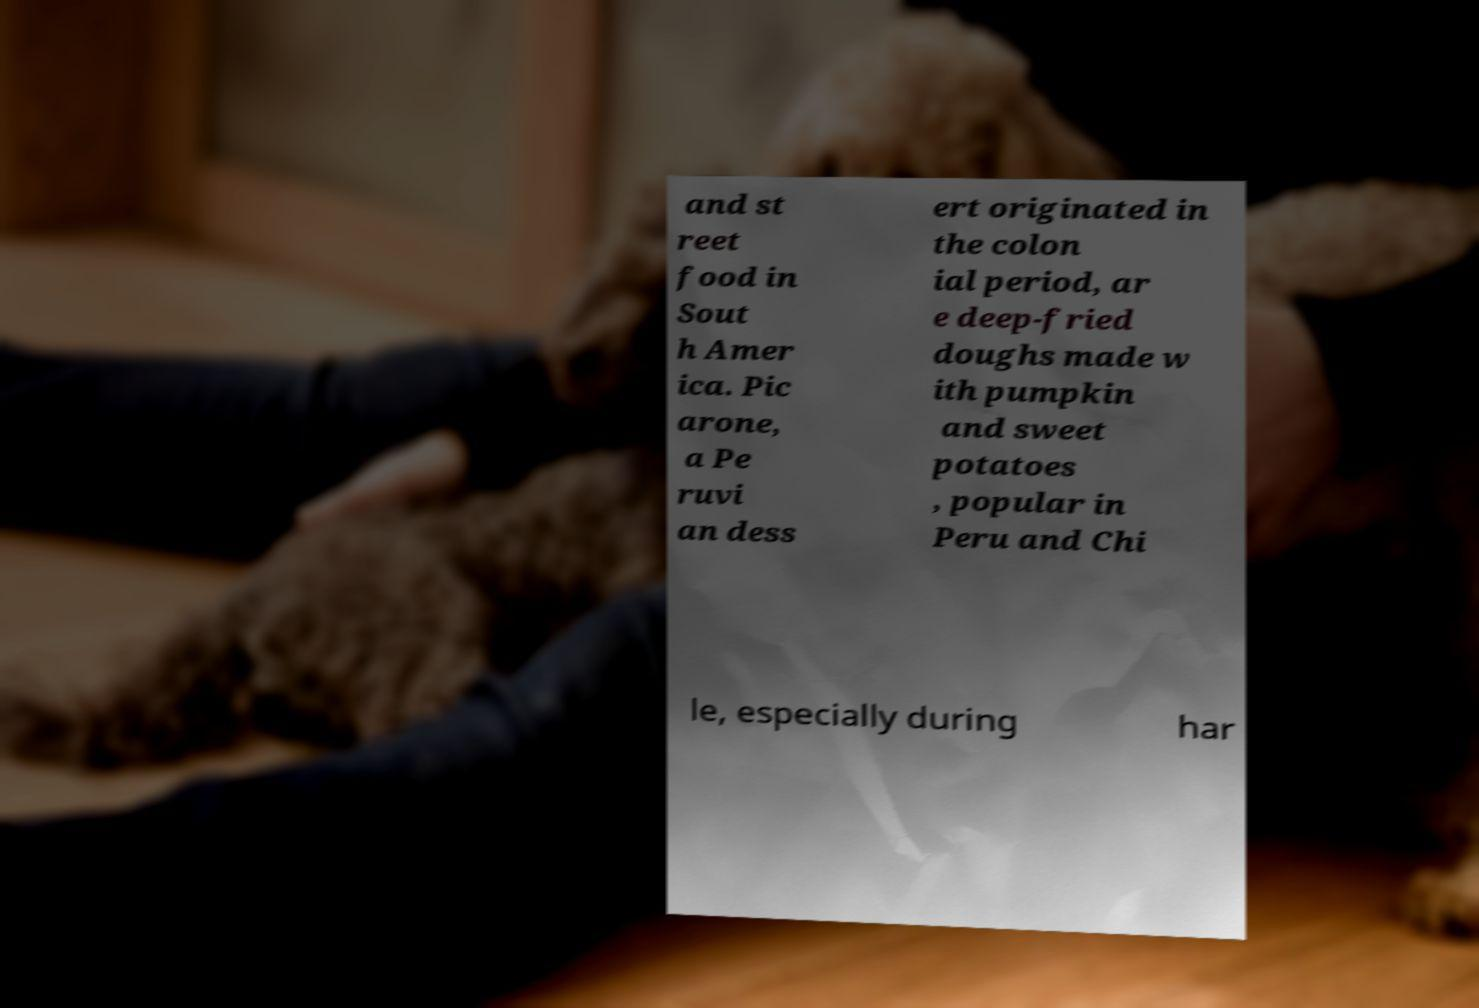Could you extract and type out the text from this image? and st reet food in Sout h Amer ica. Pic arone, a Pe ruvi an dess ert originated in the colon ial period, ar e deep-fried doughs made w ith pumpkin and sweet potatoes , popular in Peru and Chi le, especially during har 